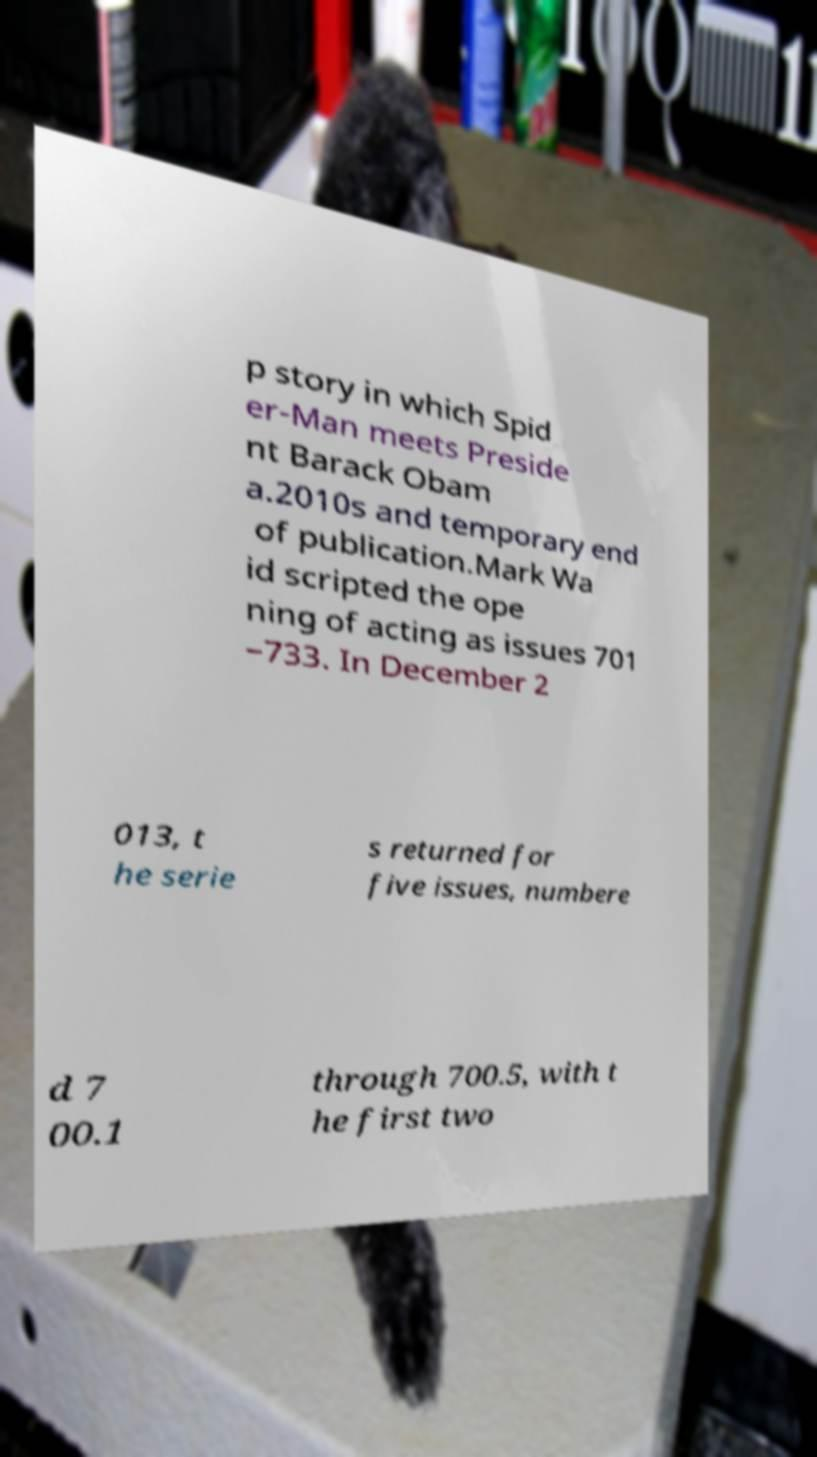Please identify and transcribe the text found in this image. p story in which Spid er-Man meets Preside nt Barack Obam a.2010s and temporary end of publication.Mark Wa id scripted the ope ning of acting as issues 701 –733. In December 2 013, t he serie s returned for five issues, numbere d 7 00.1 through 700.5, with t he first two 